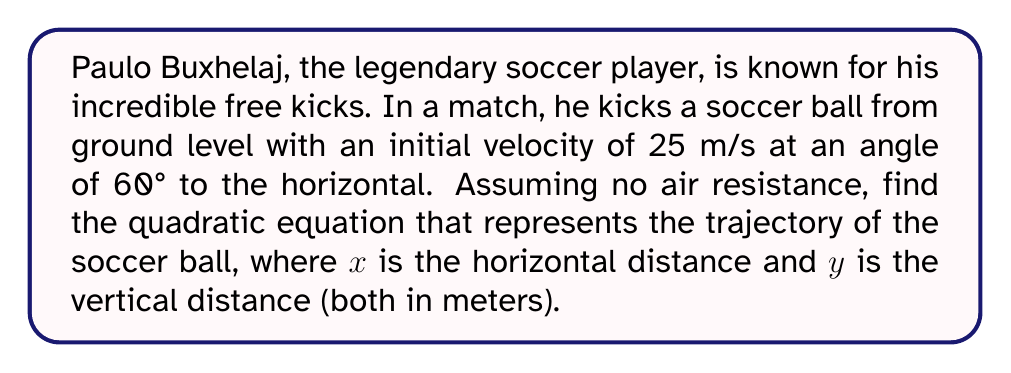Provide a solution to this math problem. To find the quadratic equation representing the trajectory of the soccer ball, we'll follow these steps:

1) The general form of a projectile motion equation is:

   $y = -\frac{1}{2}g(\frac{x}{v_x})^2 + \tan(\theta)x + h$

   Where:
   $g$ is the acceleration due to gravity (9.8 m/s²)
   $v_x$ is the initial horizontal velocity
   $\theta$ is the launch angle
   $h$ is the initial height (0 in this case)

2) Calculate the initial horizontal velocity $(v_x)$:
   $v_x = v \cos(\theta) = 25 \cos(60°) = 25 \cdot 0.5 = 12.5$ m/s

3) Calculate $\tan(\theta)$:
   $\tan(60°) = \sqrt{3} \approx 1.732$

4) Substitute these values into the general equation:

   $y = -\frac{1}{2}(9.8)(\frac{x}{12.5})^2 + 1.732x + 0$

5) Simplify:
   $y = -0.0313x^2 + 1.732x$

This is the quadratic equation representing the trajectory of the soccer ball kicked by Paulo Buxhelaj.
Answer: $y = -0.0313x^2 + 1.732x$ 